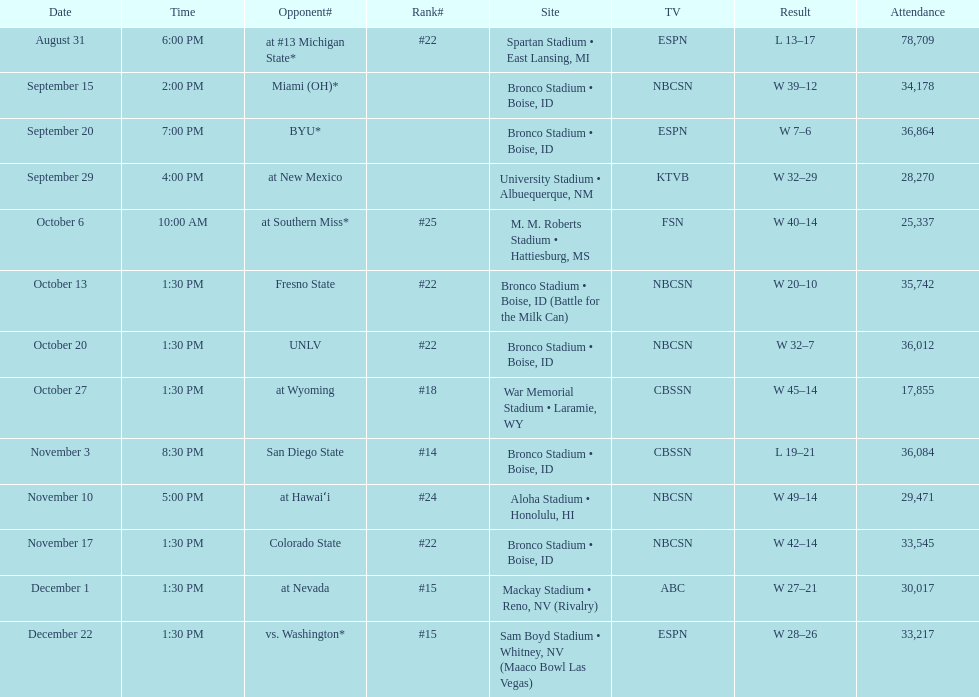What was the peak position they achieved in the season? #14. 